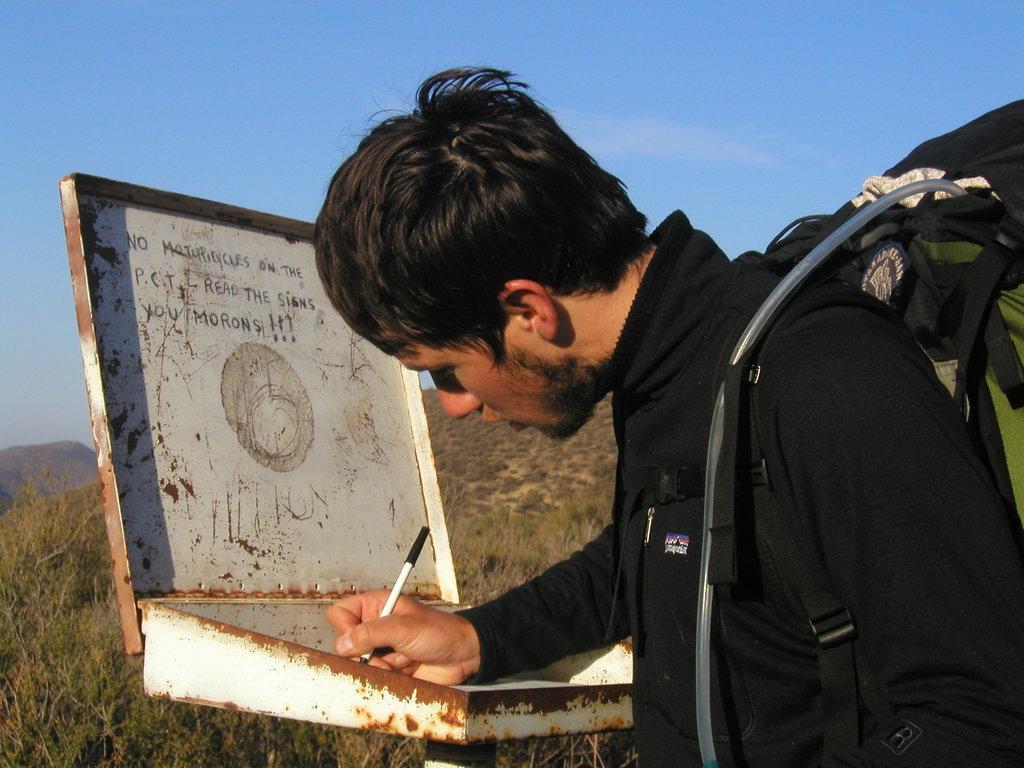Please provide a concise description of this image. In this image we can see a man holding a pen and writing something. In the background we can see hills, trees and sky. 